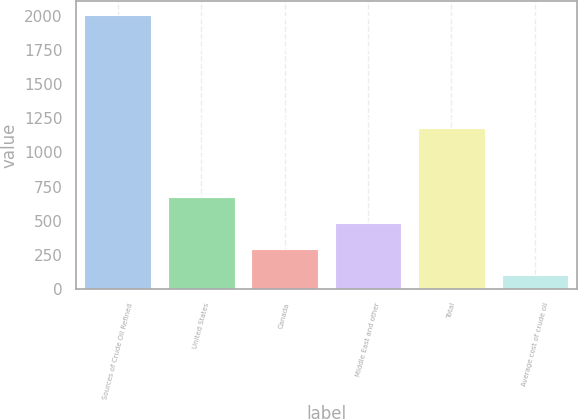<chart> <loc_0><loc_0><loc_500><loc_500><bar_chart><fcel>Sources of Crude Oil Refined<fcel>United States<fcel>Canada<fcel>Middle East and other<fcel>Total<fcel>Average cost of crude oil<nl><fcel>2011<fcel>675.29<fcel>293.65<fcel>484.47<fcel>1177<fcel>102.83<nl></chart> 